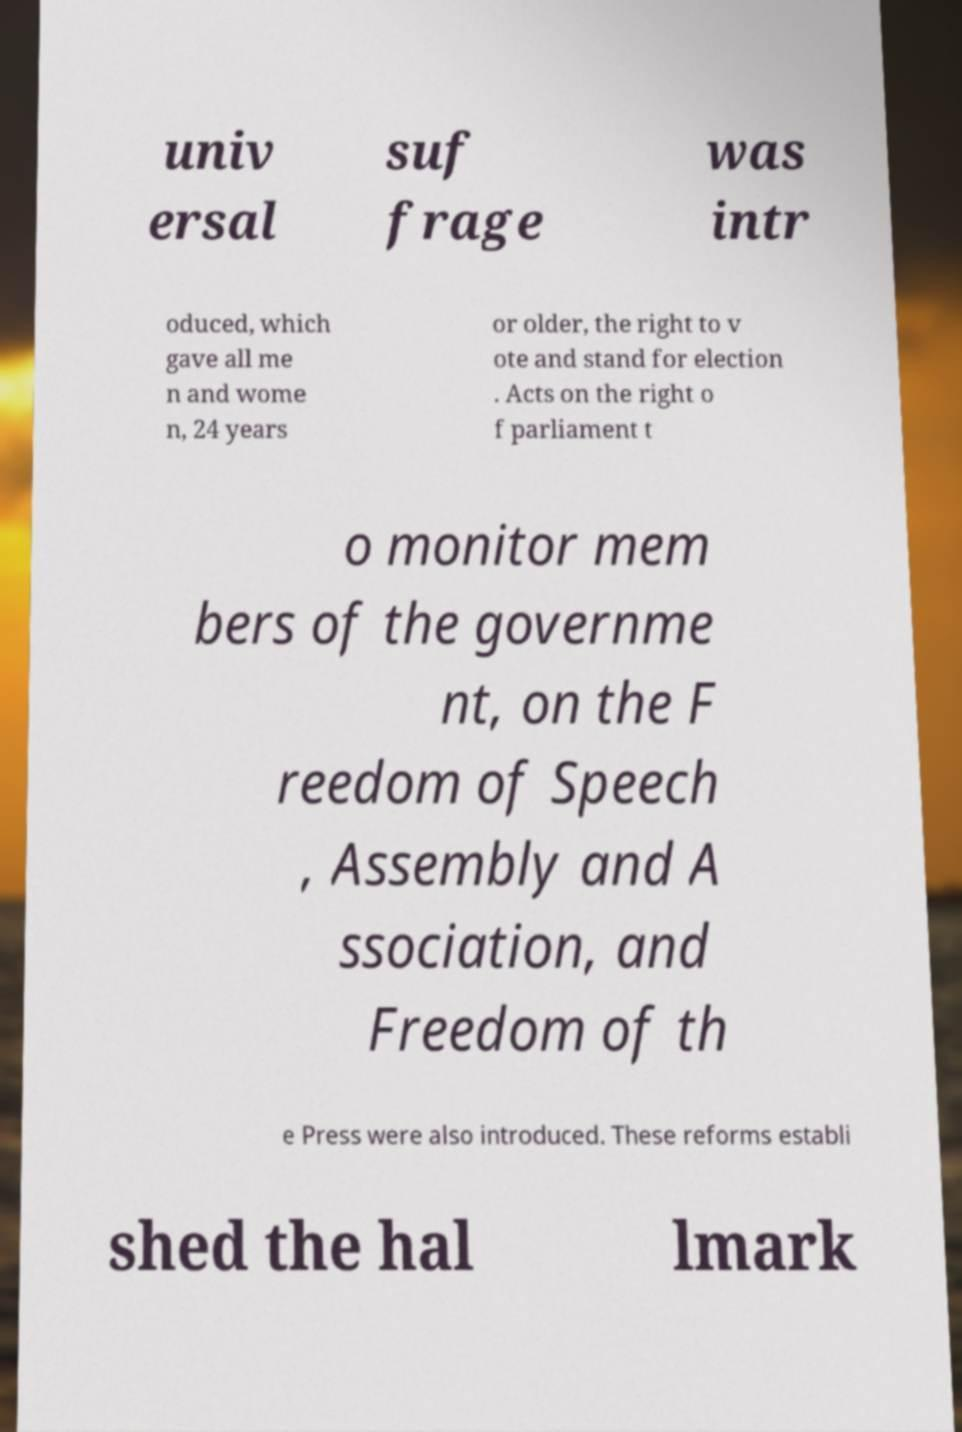Could you extract and type out the text from this image? univ ersal suf frage was intr oduced, which gave all me n and wome n, 24 years or older, the right to v ote and stand for election . Acts on the right o f parliament t o monitor mem bers of the governme nt, on the F reedom of Speech , Assembly and A ssociation, and Freedom of th e Press were also introduced. These reforms establi shed the hal lmark 